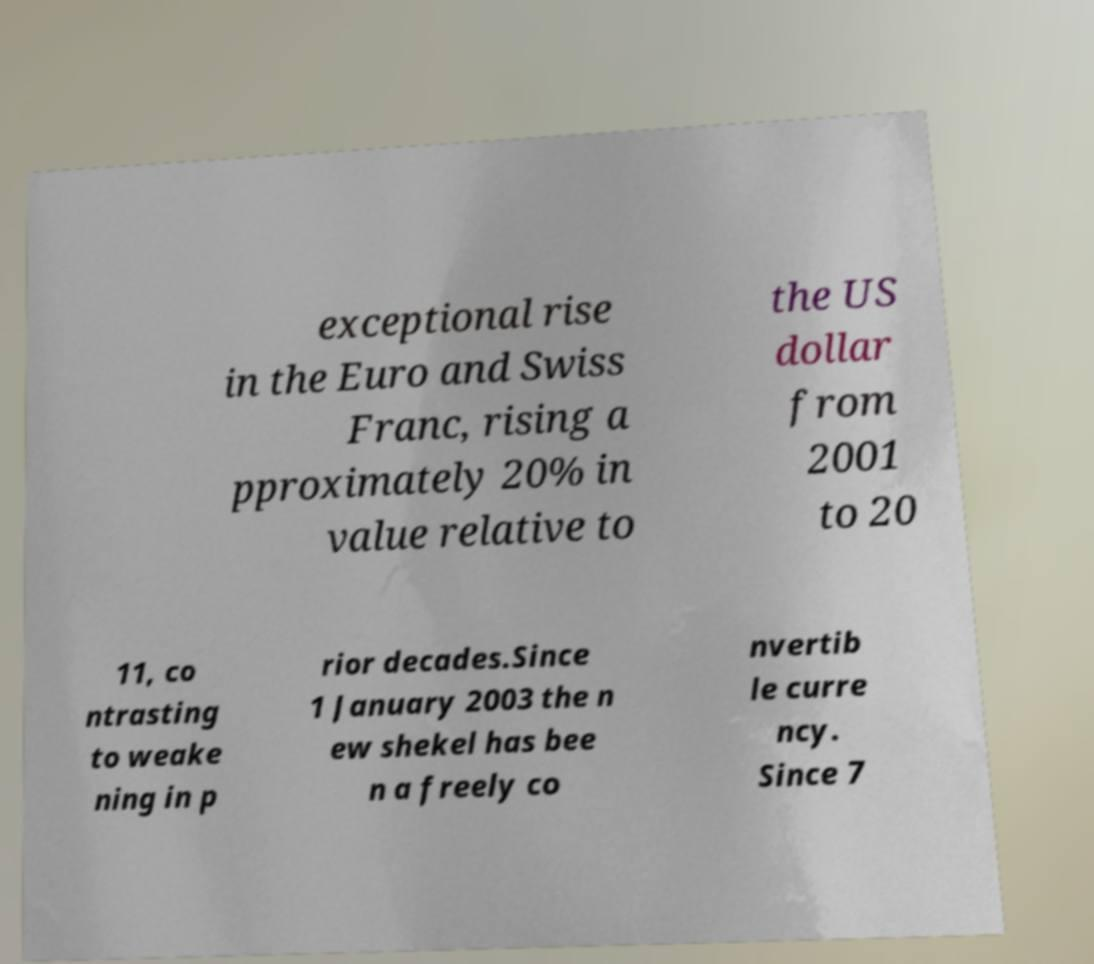Please identify and transcribe the text found in this image. exceptional rise in the Euro and Swiss Franc, rising a pproximately 20% in value relative to the US dollar from 2001 to 20 11, co ntrasting to weake ning in p rior decades.Since 1 January 2003 the n ew shekel has bee n a freely co nvertib le curre ncy. Since 7 